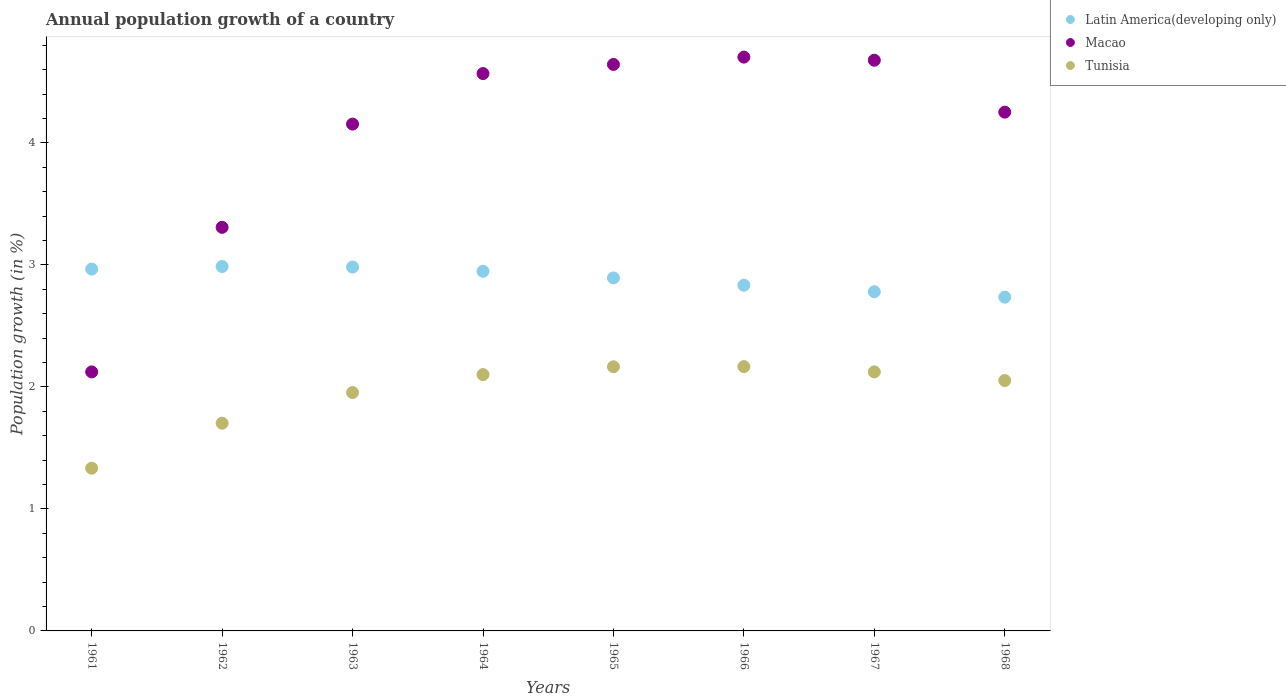How many different coloured dotlines are there?
Provide a succinct answer. 3. Is the number of dotlines equal to the number of legend labels?
Your answer should be very brief. Yes. What is the annual population growth in Macao in 1968?
Offer a very short reply. 4.25. Across all years, what is the maximum annual population growth in Latin America(developing only)?
Keep it short and to the point. 2.99. Across all years, what is the minimum annual population growth in Tunisia?
Your answer should be very brief. 1.33. In which year was the annual population growth in Tunisia maximum?
Provide a short and direct response. 1966. In which year was the annual population growth in Latin America(developing only) minimum?
Your answer should be very brief. 1968. What is the total annual population growth in Latin America(developing only) in the graph?
Make the answer very short. 23.13. What is the difference between the annual population growth in Latin America(developing only) in 1961 and that in 1963?
Your response must be concise. -0.02. What is the difference between the annual population growth in Latin America(developing only) in 1966 and the annual population growth in Tunisia in 1961?
Give a very brief answer. 1.5. What is the average annual population growth in Latin America(developing only) per year?
Offer a terse response. 2.89. In the year 1961, what is the difference between the annual population growth in Tunisia and annual population growth in Macao?
Keep it short and to the point. -0.79. In how many years, is the annual population growth in Tunisia greater than 1 %?
Offer a very short reply. 8. What is the ratio of the annual population growth in Macao in 1965 to that in 1967?
Your answer should be very brief. 0.99. Is the annual population growth in Macao in 1961 less than that in 1965?
Make the answer very short. Yes. Is the difference between the annual population growth in Tunisia in 1966 and 1967 greater than the difference between the annual population growth in Macao in 1966 and 1967?
Your response must be concise. Yes. What is the difference between the highest and the second highest annual population growth in Latin America(developing only)?
Offer a terse response. 0. What is the difference between the highest and the lowest annual population growth in Latin America(developing only)?
Offer a terse response. 0.25. In how many years, is the annual population growth in Tunisia greater than the average annual population growth in Tunisia taken over all years?
Provide a succinct answer. 6. Is the annual population growth in Latin America(developing only) strictly greater than the annual population growth in Macao over the years?
Offer a very short reply. No. How many dotlines are there?
Your answer should be very brief. 3. What is the difference between two consecutive major ticks on the Y-axis?
Give a very brief answer. 1. Does the graph contain grids?
Provide a short and direct response. No. How many legend labels are there?
Offer a terse response. 3. How are the legend labels stacked?
Give a very brief answer. Vertical. What is the title of the graph?
Ensure brevity in your answer.  Annual population growth of a country. Does "Bangladesh" appear as one of the legend labels in the graph?
Give a very brief answer. No. What is the label or title of the X-axis?
Keep it short and to the point. Years. What is the label or title of the Y-axis?
Your answer should be compact. Population growth (in %). What is the Population growth (in %) of Latin America(developing only) in 1961?
Your response must be concise. 2.97. What is the Population growth (in %) in Macao in 1961?
Provide a short and direct response. 2.12. What is the Population growth (in %) in Tunisia in 1961?
Your answer should be compact. 1.33. What is the Population growth (in %) of Latin America(developing only) in 1962?
Make the answer very short. 2.99. What is the Population growth (in %) in Macao in 1962?
Make the answer very short. 3.31. What is the Population growth (in %) of Tunisia in 1962?
Offer a terse response. 1.7. What is the Population growth (in %) in Latin America(developing only) in 1963?
Ensure brevity in your answer.  2.98. What is the Population growth (in %) in Macao in 1963?
Provide a short and direct response. 4.15. What is the Population growth (in %) of Tunisia in 1963?
Your response must be concise. 1.95. What is the Population growth (in %) in Latin America(developing only) in 1964?
Your answer should be compact. 2.95. What is the Population growth (in %) of Macao in 1964?
Offer a terse response. 4.57. What is the Population growth (in %) of Tunisia in 1964?
Give a very brief answer. 2.1. What is the Population growth (in %) of Latin America(developing only) in 1965?
Provide a succinct answer. 2.89. What is the Population growth (in %) in Macao in 1965?
Provide a short and direct response. 4.64. What is the Population growth (in %) of Tunisia in 1965?
Offer a very short reply. 2.17. What is the Population growth (in %) of Latin America(developing only) in 1966?
Provide a short and direct response. 2.83. What is the Population growth (in %) in Macao in 1966?
Give a very brief answer. 4.7. What is the Population growth (in %) in Tunisia in 1966?
Ensure brevity in your answer.  2.17. What is the Population growth (in %) in Latin America(developing only) in 1967?
Offer a very short reply. 2.78. What is the Population growth (in %) of Macao in 1967?
Keep it short and to the point. 4.68. What is the Population growth (in %) in Tunisia in 1967?
Give a very brief answer. 2.12. What is the Population growth (in %) of Latin America(developing only) in 1968?
Offer a very short reply. 2.74. What is the Population growth (in %) in Macao in 1968?
Your response must be concise. 4.25. What is the Population growth (in %) of Tunisia in 1968?
Make the answer very short. 2.05. Across all years, what is the maximum Population growth (in %) in Latin America(developing only)?
Your answer should be compact. 2.99. Across all years, what is the maximum Population growth (in %) in Macao?
Offer a very short reply. 4.7. Across all years, what is the maximum Population growth (in %) in Tunisia?
Offer a very short reply. 2.17. Across all years, what is the minimum Population growth (in %) in Latin America(developing only)?
Offer a terse response. 2.74. Across all years, what is the minimum Population growth (in %) of Macao?
Make the answer very short. 2.12. Across all years, what is the minimum Population growth (in %) in Tunisia?
Keep it short and to the point. 1.33. What is the total Population growth (in %) of Latin America(developing only) in the graph?
Offer a terse response. 23.13. What is the total Population growth (in %) in Macao in the graph?
Ensure brevity in your answer.  32.43. What is the total Population growth (in %) of Tunisia in the graph?
Provide a short and direct response. 15.6. What is the difference between the Population growth (in %) in Latin America(developing only) in 1961 and that in 1962?
Offer a terse response. -0.02. What is the difference between the Population growth (in %) in Macao in 1961 and that in 1962?
Your response must be concise. -1.18. What is the difference between the Population growth (in %) of Tunisia in 1961 and that in 1962?
Make the answer very short. -0.37. What is the difference between the Population growth (in %) in Latin America(developing only) in 1961 and that in 1963?
Your answer should be very brief. -0.02. What is the difference between the Population growth (in %) of Macao in 1961 and that in 1963?
Provide a short and direct response. -2.03. What is the difference between the Population growth (in %) in Tunisia in 1961 and that in 1963?
Provide a succinct answer. -0.62. What is the difference between the Population growth (in %) in Latin America(developing only) in 1961 and that in 1964?
Ensure brevity in your answer.  0.02. What is the difference between the Population growth (in %) of Macao in 1961 and that in 1964?
Your answer should be very brief. -2.44. What is the difference between the Population growth (in %) of Tunisia in 1961 and that in 1964?
Provide a short and direct response. -0.77. What is the difference between the Population growth (in %) of Latin America(developing only) in 1961 and that in 1965?
Make the answer very short. 0.07. What is the difference between the Population growth (in %) in Macao in 1961 and that in 1965?
Ensure brevity in your answer.  -2.52. What is the difference between the Population growth (in %) of Tunisia in 1961 and that in 1965?
Provide a succinct answer. -0.83. What is the difference between the Population growth (in %) of Latin America(developing only) in 1961 and that in 1966?
Provide a succinct answer. 0.13. What is the difference between the Population growth (in %) of Macao in 1961 and that in 1966?
Offer a terse response. -2.58. What is the difference between the Population growth (in %) in Tunisia in 1961 and that in 1966?
Offer a terse response. -0.83. What is the difference between the Population growth (in %) of Latin America(developing only) in 1961 and that in 1967?
Your answer should be compact. 0.19. What is the difference between the Population growth (in %) of Macao in 1961 and that in 1967?
Your answer should be very brief. -2.55. What is the difference between the Population growth (in %) in Tunisia in 1961 and that in 1967?
Keep it short and to the point. -0.79. What is the difference between the Population growth (in %) of Latin America(developing only) in 1961 and that in 1968?
Provide a short and direct response. 0.23. What is the difference between the Population growth (in %) in Macao in 1961 and that in 1968?
Your answer should be very brief. -2.13. What is the difference between the Population growth (in %) of Tunisia in 1961 and that in 1968?
Give a very brief answer. -0.72. What is the difference between the Population growth (in %) of Latin America(developing only) in 1962 and that in 1963?
Give a very brief answer. 0. What is the difference between the Population growth (in %) in Macao in 1962 and that in 1963?
Offer a very short reply. -0.85. What is the difference between the Population growth (in %) of Tunisia in 1962 and that in 1963?
Offer a very short reply. -0.25. What is the difference between the Population growth (in %) of Latin America(developing only) in 1962 and that in 1964?
Provide a short and direct response. 0.04. What is the difference between the Population growth (in %) of Macao in 1962 and that in 1964?
Make the answer very short. -1.26. What is the difference between the Population growth (in %) in Tunisia in 1962 and that in 1964?
Your answer should be very brief. -0.4. What is the difference between the Population growth (in %) of Latin America(developing only) in 1962 and that in 1965?
Ensure brevity in your answer.  0.09. What is the difference between the Population growth (in %) in Macao in 1962 and that in 1965?
Ensure brevity in your answer.  -1.34. What is the difference between the Population growth (in %) of Tunisia in 1962 and that in 1965?
Make the answer very short. -0.46. What is the difference between the Population growth (in %) of Latin America(developing only) in 1962 and that in 1966?
Keep it short and to the point. 0.15. What is the difference between the Population growth (in %) in Macao in 1962 and that in 1966?
Provide a short and direct response. -1.4. What is the difference between the Population growth (in %) of Tunisia in 1962 and that in 1966?
Provide a succinct answer. -0.46. What is the difference between the Population growth (in %) in Latin America(developing only) in 1962 and that in 1967?
Your answer should be compact. 0.21. What is the difference between the Population growth (in %) in Macao in 1962 and that in 1967?
Provide a short and direct response. -1.37. What is the difference between the Population growth (in %) in Tunisia in 1962 and that in 1967?
Your response must be concise. -0.42. What is the difference between the Population growth (in %) of Latin America(developing only) in 1962 and that in 1968?
Offer a terse response. 0.25. What is the difference between the Population growth (in %) of Macao in 1962 and that in 1968?
Provide a succinct answer. -0.94. What is the difference between the Population growth (in %) of Tunisia in 1962 and that in 1968?
Keep it short and to the point. -0.35. What is the difference between the Population growth (in %) in Latin America(developing only) in 1963 and that in 1964?
Your answer should be very brief. 0.03. What is the difference between the Population growth (in %) of Macao in 1963 and that in 1964?
Make the answer very short. -0.41. What is the difference between the Population growth (in %) in Tunisia in 1963 and that in 1964?
Make the answer very short. -0.15. What is the difference between the Population growth (in %) of Latin America(developing only) in 1963 and that in 1965?
Your answer should be very brief. 0.09. What is the difference between the Population growth (in %) of Macao in 1963 and that in 1965?
Keep it short and to the point. -0.49. What is the difference between the Population growth (in %) of Tunisia in 1963 and that in 1965?
Provide a short and direct response. -0.21. What is the difference between the Population growth (in %) of Latin America(developing only) in 1963 and that in 1966?
Give a very brief answer. 0.15. What is the difference between the Population growth (in %) of Macao in 1963 and that in 1966?
Provide a succinct answer. -0.55. What is the difference between the Population growth (in %) in Tunisia in 1963 and that in 1966?
Make the answer very short. -0.21. What is the difference between the Population growth (in %) in Latin America(developing only) in 1963 and that in 1967?
Offer a terse response. 0.2. What is the difference between the Population growth (in %) in Macao in 1963 and that in 1967?
Make the answer very short. -0.52. What is the difference between the Population growth (in %) of Tunisia in 1963 and that in 1967?
Provide a short and direct response. -0.17. What is the difference between the Population growth (in %) in Latin America(developing only) in 1963 and that in 1968?
Provide a succinct answer. 0.25. What is the difference between the Population growth (in %) of Macao in 1963 and that in 1968?
Give a very brief answer. -0.1. What is the difference between the Population growth (in %) in Tunisia in 1963 and that in 1968?
Provide a succinct answer. -0.1. What is the difference between the Population growth (in %) in Latin America(developing only) in 1964 and that in 1965?
Your answer should be very brief. 0.05. What is the difference between the Population growth (in %) of Macao in 1964 and that in 1965?
Provide a short and direct response. -0.07. What is the difference between the Population growth (in %) of Tunisia in 1964 and that in 1965?
Your answer should be very brief. -0.06. What is the difference between the Population growth (in %) in Latin America(developing only) in 1964 and that in 1966?
Your answer should be very brief. 0.11. What is the difference between the Population growth (in %) of Macao in 1964 and that in 1966?
Offer a terse response. -0.13. What is the difference between the Population growth (in %) of Tunisia in 1964 and that in 1966?
Provide a short and direct response. -0.07. What is the difference between the Population growth (in %) in Latin America(developing only) in 1964 and that in 1967?
Your answer should be compact. 0.17. What is the difference between the Population growth (in %) of Macao in 1964 and that in 1967?
Your answer should be very brief. -0.11. What is the difference between the Population growth (in %) in Tunisia in 1964 and that in 1967?
Make the answer very short. -0.02. What is the difference between the Population growth (in %) of Latin America(developing only) in 1964 and that in 1968?
Provide a short and direct response. 0.21. What is the difference between the Population growth (in %) of Macao in 1964 and that in 1968?
Make the answer very short. 0.32. What is the difference between the Population growth (in %) in Tunisia in 1964 and that in 1968?
Offer a very short reply. 0.05. What is the difference between the Population growth (in %) in Latin America(developing only) in 1965 and that in 1966?
Make the answer very short. 0.06. What is the difference between the Population growth (in %) in Macao in 1965 and that in 1966?
Your response must be concise. -0.06. What is the difference between the Population growth (in %) of Tunisia in 1965 and that in 1966?
Provide a succinct answer. -0. What is the difference between the Population growth (in %) in Latin America(developing only) in 1965 and that in 1967?
Offer a very short reply. 0.11. What is the difference between the Population growth (in %) of Macao in 1965 and that in 1967?
Keep it short and to the point. -0.03. What is the difference between the Population growth (in %) in Tunisia in 1965 and that in 1967?
Offer a very short reply. 0.04. What is the difference between the Population growth (in %) of Latin America(developing only) in 1965 and that in 1968?
Ensure brevity in your answer.  0.16. What is the difference between the Population growth (in %) in Macao in 1965 and that in 1968?
Ensure brevity in your answer.  0.39. What is the difference between the Population growth (in %) of Tunisia in 1965 and that in 1968?
Your response must be concise. 0.11. What is the difference between the Population growth (in %) of Latin America(developing only) in 1966 and that in 1967?
Ensure brevity in your answer.  0.05. What is the difference between the Population growth (in %) of Macao in 1966 and that in 1967?
Your answer should be very brief. 0.03. What is the difference between the Population growth (in %) of Tunisia in 1966 and that in 1967?
Give a very brief answer. 0.04. What is the difference between the Population growth (in %) in Latin America(developing only) in 1966 and that in 1968?
Offer a terse response. 0.1. What is the difference between the Population growth (in %) in Macao in 1966 and that in 1968?
Keep it short and to the point. 0.45. What is the difference between the Population growth (in %) in Tunisia in 1966 and that in 1968?
Provide a succinct answer. 0.11. What is the difference between the Population growth (in %) in Latin America(developing only) in 1967 and that in 1968?
Your response must be concise. 0.04. What is the difference between the Population growth (in %) of Macao in 1967 and that in 1968?
Make the answer very short. 0.43. What is the difference between the Population growth (in %) in Tunisia in 1967 and that in 1968?
Your response must be concise. 0.07. What is the difference between the Population growth (in %) of Latin America(developing only) in 1961 and the Population growth (in %) of Macao in 1962?
Offer a very short reply. -0.34. What is the difference between the Population growth (in %) in Latin America(developing only) in 1961 and the Population growth (in %) in Tunisia in 1962?
Your answer should be very brief. 1.26. What is the difference between the Population growth (in %) in Macao in 1961 and the Population growth (in %) in Tunisia in 1962?
Ensure brevity in your answer.  0.42. What is the difference between the Population growth (in %) of Latin America(developing only) in 1961 and the Population growth (in %) of Macao in 1963?
Offer a very short reply. -1.19. What is the difference between the Population growth (in %) of Latin America(developing only) in 1961 and the Population growth (in %) of Tunisia in 1963?
Provide a succinct answer. 1.01. What is the difference between the Population growth (in %) of Macao in 1961 and the Population growth (in %) of Tunisia in 1963?
Your response must be concise. 0.17. What is the difference between the Population growth (in %) in Latin America(developing only) in 1961 and the Population growth (in %) in Macao in 1964?
Make the answer very short. -1.6. What is the difference between the Population growth (in %) in Latin America(developing only) in 1961 and the Population growth (in %) in Tunisia in 1964?
Your answer should be very brief. 0.86. What is the difference between the Population growth (in %) of Macao in 1961 and the Population growth (in %) of Tunisia in 1964?
Your answer should be compact. 0.02. What is the difference between the Population growth (in %) of Latin America(developing only) in 1961 and the Population growth (in %) of Macao in 1965?
Provide a succinct answer. -1.68. What is the difference between the Population growth (in %) in Latin America(developing only) in 1961 and the Population growth (in %) in Tunisia in 1965?
Your answer should be very brief. 0.8. What is the difference between the Population growth (in %) of Macao in 1961 and the Population growth (in %) of Tunisia in 1965?
Your answer should be compact. -0.04. What is the difference between the Population growth (in %) of Latin America(developing only) in 1961 and the Population growth (in %) of Macao in 1966?
Your response must be concise. -1.74. What is the difference between the Population growth (in %) in Latin America(developing only) in 1961 and the Population growth (in %) in Tunisia in 1966?
Offer a very short reply. 0.8. What is the difference between the Population growth (in %) in Macao in 1961 and the Population growth (in %) in Tunisia in 1966?
Make the answer very short. -0.04. What is the difference between the Population growth (in %) in Latin America(developing only) in 1961 and the Population growth (in %) in Macao in 1967?
Give a very brief answer. -1.71. What is the difference between the Population growth (in %) in Latin America(developing only) in 1961 and the Population growth (in %) in Tunisia in 1967?
Make the answer very short. 0.84. What is the difference between the Population growth (in %) in Macao in 1961 and the Population growth (in %) in Tunisia in 1967?
Offer a very short reply. -0. What is the difference between the Population growth (in %) of Latin America(developing only) in 1961 and the Population growth (in %) of Macao in 1968?
Offer a terse response. -1.29. What is the difference between the Population growth (in %) in Latin America(developing only) in 1961 and the Population growth (in %) in Tunisia in 1968?
Your response must be concise. 0.91. What is the difference between the Population growth (in %) in Macao in 1961 and the Population growth (in %) in Tunisia in 1968?
Offer a very short reply. 0.07. What is the difference between the Population growth (in %) in Latin America(developing only) in 1962 and the Population growth (in %) in Macao in 1963?
Ensure brevity in your answer.  -1.17. What is the difference between the Population growth (in %) of Latin America(developing only) in 1962 and the Population growth (in %) of Tunisia in 1963?
Your answer should be very brief. 1.03. What is the difference between the Population growth (in %) of Macao in 1962 and the Population growth (in %) of Tunisia in 1963?
Your response must be concise. 1.35. What is the difference between the Population growth (in %) of Latin America(developing only) in 1962 and the Population growth (in %) of Macao in 1964?
Make the answer very short. -1.58. What is the difference between the Population growth (in %) in Latin America(developing only) in 1962 and the Population growth (in %) in Tunisia in 1964?
Ensure brevity in your answer.  0.89. What is the difference between the Population growth (in %) of Macao in 1962 and the Population growth (in %) of Tunisia in 1964?
Your answer should be very brief. 1.21. What is the difference between the Population growth (in %) in Latin America(developing only) in 1962 and the Population growth (in %) in Macao in 1965?
Make the answer very short. -1.66. What is the difference between the Population growth (in %) of Latin America(developing only) in 1962 and the Population growth (in %) of Tunisia in 1965?
Ensure brevity in your answer.  0.82. What is the difference between the Population growth (in %) in Macao in 1962 and the Population growth (in %) in Tunisia in 1965?
Provide a succinct answer. 1.14. What is the difference between the Population growth (in %) of Latin America(developing only) in 1962 and the Population growth (in %) of Macao in 1966?
Ensure brevity in your answer.  -1.72. What is the difference between the Population growth (in %) of Latin America(developing only) in 1962 and the Population growth (in %) of Tunisia in 1966?
Ensure brevity in your answer.  0.82. What is the difference between the Population growth (in %) in Macao in 1962 and the Population growth (in %) in Tunisia in 1966?
Provide a succinct answer. 1.14. What is the difference between the Population growth (in %) of Latin America(developing only) in 1962 and the Population growth (in %) of Macao in 1967?
Keep it short and to the point. -1.69. What is the difference between the Population growth (in %) of Latin America(developing only) in 1962 and the Population growth (in %) of Tunisia in 1967?
Offer a terse response. 0.86. What is the difference between the Population growth (in %) in Macao in 1962 and the Population growth (in %) in Tunisia in 1967?
Provide a succinct answer. 1.18. What is the difference between the Population growth (in %) of Latin America(developing only) in 1962 and the Population growth (in %) of Macao in 1968?
Give a very brief answer. -1.27. What is the difference between the Population growth (in %) in Latin America(developing only) in 1962 and the Population growth (in %) in Tunisia in 1968?
Your answer should be very brief. 0.93. What is the difference between the Population growth (in %) of Macao in 1962 and the Population growth (in %) of Tunisia in 1968?
Your answer should be very brief. 1.26. What is the difference between the Population growth (in %) of Latin America(developing only) in 1963 and the Population growth (in %) of Macao in 1964?
Offer a very short reply. -1.59. What is the difference between the Population growth (in %) in Latin America(developing only) in 1963 and the Population growth (in %) in Tunisia in 1964?
Provide a short and direct response. 0.88. What is the difference between the Population growth (in %) of Macao in 1963 and the Population growth (in %) of Tunisia in 1964?
Ensure brevity in your answer.  2.05. What is the difference between the Population growth (in %) of Latin America(developing only) in 1963 and the Population growth (in %) of Macao in 1965?
Provide a short and direct response. -1.66. What is the difference between the Population growth (in %) of Latin America(developing only) in 1963 and the Population growth (in %) of Tunisia in 1965?
Your answer should be compact. 0.82. What is the difference between the Population growth (in %) of Macao in 1963 and the Population growth (in %) of Tunisia in 1965?
Provide a short and direct response. 1.99. What is the difference between the Population growth (in %) in Latin America(developing only) in 1963 and the Population growth (in %) in Macao in 1966?
Provide a short and direct response. -1.72. What is the difference between the Population growth (in %) in Latin America(developing only) in 1963 and the Population growth (in %) in Tunisia in 1966?
Give a very brief answer. 0.82. What is the difference between the Population growth (in %) of Macao in 1963 and the Population growth (in %) of Tunisia in 1966?
Provide a succinct answer. 1.99. What is the difference between the Population growth (in %) of Latin America(developing only) in 1963 and the Population growth (in %) of Macao in 1967?
Give a very brief answer. -1.7. What is the difference between the Population growth (in %) in Latin America(developing only) in 1963 and the Population growth (in %) in Tunisia in 1967?
Your response must be concise. 0.86. What is the difference between the Population growth (in %) in Macao in 1963 and the Population growth (in %) in Tunisia in 1967?
Keep it short and to the point. 2.03. What is the difference between the Population growth (in %) of Latin America(developing only) in 1963 and the Population growth (in %) of Macao in 1968?
Your answer should be compact. -1.27. What is the difference between the Population growth (in %) in Latin America(developing only) in 1963 and the Population growth (in %) in Tunisia in 1968?
Keep it short and to the point. 0.93. What is the difference between the Population growth (in %) in Macao in 1963 and the Population growth (in %) in Tunisia in 1968?
Provide a succinct answer. 2.1. What is the difference between the Population growth (in %) in Latin America(developing only) in 1964 and the Population growth (in %) in Macao in 1965?
Keep it short and to the point. -1.7. What is the difference between the Population growth (in %) of Latin America(developing only) in 1964 and the Population growth (in %) of Tunisia in 1965?
Give a very brief answer. 0.78. What is the difference between the Population growth (in %) of Macao in 1964 and the Population growth (in %) of Tunisia in 1965?
Ensure brevity in your answer.  2.4. What is the difference between the Population growth (in %) of Latin America(developing only) in 1964 and the Population growth (in %) of Macao in 1966?
Give a very brief answer. -1.76. What is the difference between the Population growth (in %) of Latin America(developing only) in 1964 and the Population growth (in %) of Tunisia in 1966?
Provide a succinct answer. 0.78. What is the difference between the Population growth (in %) of Macao in 1964 and the Population growth (in %) of Tunisia in 1966?
Your response must be concise. 2.4. What is the difference between the Population growth (in %) in Latin America(developing only) in 1964 and the Population growth (in %) in Macao in 1967?
Your response must be concise. -1.73. What is the difference between the Population growth (in %) of Latin America(developing only) in 1964 and the Population growth (in %) of Tunisia in 1967?
Make the answer very short. 0.82. What is the difference between the Population growth (in %) in Macao in 1964 and the Population growth (in %) in Tunisia in 1967?
Provide a short and direct response. 2.44. What is the difference between the Population growth (in %) of Latin America(developing only) in 1964 and the Population growth (in %) of Macao in 1968?
Keep it short and to the point. -1.3. What is the difference between the Population growth (in %) in Latin America(developing only) in 1964 and the Population growth (in %) in Tunisia in 1968?
Your answer should be compact. 0.9. What is the difference between the Population growth (in %) of Macao in 1964 and the Population growth (in %) of Tunisia in 1968?
Ensure brevity in your answer.  2.52. What is the difference between the Population growth (in %) in Latin America(developing only) in 1965 and the Population growth (in %) in Macao in 1966?
Make the answer very short. -1.81. What is the difference between the Population growth (in %) of Latin America(developing only) in 1965 and the Population growth (in %) of Tunisia in 1966?
Make the answer very short. 0.73. What is the difference between the Population growth (in %) in Macao in 1965 and the Population growth (in %) in Tunisia in 1966?
Your response must be concise. 2.48. What is the difference between the Population growth (in %) of Latin America(developing only) in 1965 and the Population growth (in %) of Macao in 1967?
Your answer should be very brief. -1.78. What is the difference between the Population growth (in %) in Latin America(developing only) in 1965 and the Population growth (in %) in Tunisia in 1967?
Keep it short and to the point. 0.77. What is the difference between the Population growth (in %) in Macao in 1965 and the Population growth (in %) in Tunisia in 1967?
Give a very brief answer. 2.52. What is the difference between the Population growth (in %) of Latin America(developing only) in 1965 and the Population growth (in %) of Macao in 1968?
Offer a terse response. -1.36. What is the difference between the Population growth (in %) in Latin America(developing only) in 1965 and the Population growth (in %) in Tunisia in 1968?
Offer a very short reply. 0.84. What is the difference between the Population growth (in %) of Macao in 1965 and the Population growth (in %) of Tunisia in 1968?
Make the answer very short. 2.59. What is the difference between the Population growth (in %) in Latin America(developing only) in 1966 and the Population growth (in %) in Macao in 1967?
Offer a terse response. -1.84. What is the difference between the Population growth (in %) of Latin America(developing only) in 1966 and the Population growth (in %) of Tunisia in 1967?
Your answer should be very brief. 0.71. What is the difference between the Population growth (in %) in Macao in 1966 and the Population growth (in %) in Tunisia in 1967?
Provide a short and direct response. 2.58. What is the difference between the Population growth (in %) of Latin America(developing only) in 1966 and the Population growth (in %) of Macao in 1968?
Ensure brevity in your answer.  -1.42. What is the difference between the Population growth (in %) in Latin America(developing only) in 1966 and the Population growth (in %) in Tunisia in 1968?
Your answer should be very brief. 0.78. What is the difference between the Population growth (in %) of Macao in 1966 and the Population growth (in %) of Tunisia in 1968?
Offer a very short reply. 2.65. What is the difference between the Population growth (in %) in Latin America(developing only) in 1967 and the Population growth (in %) in Macao in 1968?
Offer a very short reply. -1.47. What is the difference between the Population growth (in %) of Latin America(developing only) in 1967 and the Population growth (in %) of Tunisia in 1968?
Your answer should be very brief. 0.73. What is the difference between the Population growth (in %) of Macao in 1967 and the Population growth (in %) of Tunisia in 1968?
Provide a short and direct response. 2.63. What is the average Population growth (in %) of Latin America(developing only) per year?
Provide a short and direct response. 2.89. What is the average Population growth (in %) in Macao per year?
Ensure brevity in your answer.  4.05. What is the average Population growth (in %) in Tunisia per year?
Provide a short and direct response. 1.95. In the year 1961, what is the difference between the Population growth (in %) of Latin America(developing only) and Population growth (in %) of Macao?
Your response must be concise. 0.84. In the year 1961, what is the difference between the Population growth (in %) in Latin America(developing only) and Population growth (in %) in Tunisia?
Your answer should be compact. 1.63. In the year 1961, what is the difference between the Population growth (in %) in Macao and Population growth (in %) in Tunisia?
Ensure brevity in your answer.  0.79. In the year 1962, what is the difference between the Population growth (in %) of Latin America(developing only) and Population growth (in %) of Macao?
Ensure brevity in your answer.  -0.32. In the year 1962, what is the difference between the Population growth (in %) of Latin America(developing only) and Population growth (in %) of Tunisia?
Your answer should be compact. 1.28. In the year 1962, what is the difference between the Population growth (in %) in Macao and Population growth (in %) in Tunisia?
Give a very brief answer. 1.61. In the year 1963, what is the difference between the Population growth (in %) in Latin America(developing only) and Population growth (in %) in Macao?
Your response must be concise. -1.17. In the year 1963, what is the difference between the Population growth (in %) of Latin America(developing only) and Population growth (in %) of Tunisia?
Make the answer very short. 1.03. In the year 1963, what is the difference between the Population growth (in %) of Macao and Population growth (in %) of Tunisia?
Make the answer very short. 2.2. In the year 1964, what is the difference between the Population growth (in %) in Latin America(developing only) and Population growth (in %) in Macao?
Provide a short and direct response. -1.62. In the year 1964, what is the difference between the Population growth (in %) of Latin America(developing only) and Population growth (in %) of Tunisia?
Make the answer very short. 0.85. In the year 1964, what is the difference between the Population growth (in %) in Macao and Population growth (in %) in Tunisia?
Give a very brief answer. 2.47. In the year 1965, what is the difference between the Population growth (in %) of Latin America(developing only) and Population growth (in %) of Macao?
Keep it short and to the point. -1.75. In the year 1965, what is the difference between the Population growth (in %) in Latin America(developing only) and Population growth (in %) in Tunisia?
Offer a very short reply. 0.73. In the year 1965, what is the difference between the Population growth (in %) of Macao and Population growth (in %) of Tunisia?
Provide a succinct answer. 2.48. In the year 1966, what is the difference between the Population growth (in %) of Latin America(developing only) and Population growth (in %) of Macao?
Your response must be concise. -1.87. In the year 1966, what is the difference between the Population growth (in %) in Latin America(developing only) and Population growth (in %) in Tunisia?
Your answer should be compact. 0.67. In the year 1966, what is the difference between the Population growth (in %) of Macao and Population growth (in %) of Tunisia?
Make the answer very short. 2.54. In the year 1967, what is the difference between the Population growth (in %) in Latin America(developing only) and Population growth (in %) in Macao?
Your response must be concise. -1.9. In the year 1967, what is the difference between the Population growth (in %) in Latin America(developing only) and Population growth (in %) in Tunisia?
Your answer should be compact. 0.66. In the year 1967, what is the difference between the Population growth (in %) of Macao and Population growth (in %) of Tunisia?
Provide a succinct answer. 2.55. In the year 1968, what is the difference between the Population growth (in %) in Latin America(developing only) and Population growth (in %) in Macao?
Your answer should be very brief. -1.52. In the year 1968, what is the difference between the Population growth (in %) of Latin America(developing only) and Population growth (in %) of Tunisia?
Offer a very short reply. 0.68. In the year 1968, what is the difference between the Population growth (in %) of Macao and Population growth (in %) of Tunisia?
Offer a terse response. 2.2. What is the ratio of the Population growth (in %) of Macao in 1961 to that in 1962?
Keep it short and to the point. 0.64. What is the ratio of the Population growth (in %) in Tunisia in 1961 to that in 1962?
Your answer should be compact. 0.78. What is the ratio of the Population growth (in %) in Latin America(developing only) in 1961 to that in 1963?
Give a very brief answer. 0.99. What is the ratio of the Population growth (in %) of Macao in 1961 to that in 1963?
Keep it short and to the point. 0.51. What is the ratio of the Population growth (in %) in Tunisia in 1961 to that in 1963?
Make the answer very short. 0.68. What is the ratio of the Population growth (in %) in Latin America(developing only) in 1961 to that in 1964?
Provide a succinct answer. 1.01. What is the ratio of the Population growth (in %) in Macao in 1961 to that in 1964?
Provide a short and direct response. 0.46. What is the ratio of the Population growth (in %) of Tunisia in 1961 to that in 1964?
Your answer should be very brief. 0.63. What is the ratio of the Population growth (in %) in Latin America(developing only) in 1961 to that in 1965?
Offer a very short reply. 1.03. What is the ratio of the Population growth (in %) of Macao in 1961 to that in 1965?
Your answer should be compact. 0.46. What is the ratio of the Population growth (in %) of Tunisia in 1961 to that in 1965?
Keep it short and to the point. 0.62. What is the ratio of the Population growth (in %) in Latin America(developing only) in 1961 to that in 1966?
Offer a terse response. 1.05. What is the ratio of the Population growth (in %) in Macao in 1961 to that in 1966?
Provide a short and direct response. 0.45. What is the ratio of the Population growth (in %) of Tunisia in 1961 to that in 1966?
Offer a very short reply. 0.62. What is the ratio of the Population growth (in %) of Latin America(developing only) in 1961 to that in 1967?
Provide a succinct answer. 1.07. What is the ratio of the Population growth (in %) of Macao in 1961 to that in 1967?
Ensure brevity in your answer.  0.45. What is the ratio of the Population growth (in %) of Tunisia in 1961 to that in 1967?
Keep it short and to the point. 0.63. What is the ratio of the Population growth (in %) in Latin America(developing only) in 1961 to that in 1968?
Your answer should be compact. 1.08. What is the ratio of the Population growth (in %) in Macao in 1961 to that in 1968?
Make the answer very short. 0.5. What is the ratio of the Population growth (in %) in Tunisia in 1961 to that in 1968?
Offer a very short reply. 0.65. What is the ratio of the Population growth (in %) of Latin America(developing only) in 1962 to that in 1963?
Offer a very short reply. 1. What is the ratio of the Population growth (in %) in Macao in 1962 to that in 1963?
Keep it short and to the point. 0.8. What is the ratio of the Population growth (in %) of Tunisia in 1962 to that in 1963?
Ensure brevity in your answer.  0.87. What is the ratio of the Population growth (in %) in Latin America(developing only) in 1962 to that in 1964?
Ensure brevity in your answer.  1.01. What is the ratio of the Population growth (in %) in Macao in 1962 to that in 1964?
Give a very brief answer. 0.72. What is the ratio of the Population growth (in %) in Tunisia in 1962 to that in 1964?
Offer a very short reply. 0.81. What is the ratio of the Population growth (in %) in Latin America(developing only) in 1962 to that in 1965?
Offer a very short reply. 1.03. What is the ratio of the Population growth (in %) in Macao in 1962 to that in 1965?
Your answer should be very brief. 0.71. What is the ratio of the Population growth (in %) in Tunisia in 1962 to that in 1965?
Ensure brevity in your answer.  0.79. What is the ratio of the Population growth (in %) in Latin America(developing only) in 1962 to that in 1966?
Provide a succinct answer. 1.05. What is the ratio of the Population growth (in %) of Macao in 1962 to that in 1966?
Your answer should be compact. 0.7. What is the ratio of the Population growth (in %) in Tunisia in 1962 to that in 1966?
Offer a terse response. 0.79. What is the ratio of the Population growth (in %) in Latin America(developing only) in 1962 to that in 1967?
Keep it short and to the point. 1.07. What is the ratio of the Population growth (in %) in Macao in 1962 to that in 1967?
Your response must be concise. 0.71. What is the ratio of the Population growth (in %) in Tunisia in 1962 to that in 1967?
Your response must be concise. 0.8. What is the ratio of the Population growth (in %) in Latin America(developing only) in 1962 to that in 1968?
Keep it short and to the point. 1.09. What is the ratio of the Population growth (in %) of Macao in 1962 to that in 1968?
Give a very brief answer. 0.78. What is the ratio of the Population growth (in %) of Tunisia in 1962 to that in 1968?
Your answer should be compact. 0.83. What is the ratio of the Population growth (in %) in Latin America(developing only) in 1963 to that in 1964?
Keep it short and to the point. 1.01. What is the ratio of the Population growth (in %) in Macao in 1963 to that in 1964?
Give a very brief answer. 0.91. What is the ratio of the Population growth (in %) in Tunisia in 1963 to that in 1964?
Your response must be concise. 0.93. What is the ratio of the Population growth (in %) in Latin America(developing only) in 1963 to that in 1965?
Keep it short and to the point. 1.03. What is the ratio of the Population growth (in %) in Macao in 1963 to that in 1965?
Ensure brevity in your answer.  0.89. What is the ratio of the Population growth (in %) of Tunisia in 1963 to that in 1965?
Your answer should be compact. 0.9. What is the ratio of the Population growth (in %) of Latin America(developing only) in 1963 to that in 1966?
Provide a short and direct response. 1.05. What is the ratio of the Population growth (in %) of Macao in 1963 to that in 1966?
Offer a very short reply. 0.88. What is the ratio of the Population growth (in %) in Tunisia in 1963 to that in 1966?
Provide a succinct answer. 0.9. What is the ratio of the Population growth (in %) of Latin America(developing only) in 1963 to that in 1967?
Provide a short and direct response. 1.07. What is the ratio of the Population growth (in %) of Macao in 1963 to that in 1967?
Give a very brief answer. 0.89. What is the ratio of the Population growth (in %) in Tunisia in 1963 to that in 1967?
Keep it short and to the point. 0.92. What is the ratio of the Population growth (in %) of Latin America(developing only) in 1963 to that in 1968?
Give a very brief answer. 1.09. What is the ratio of the Population growth (in %) of Tunisia in 1963 to that in 1968?
Give a very brief answer. 0.95. What is the ratio of the Population growth (in %) of Latin America(developing only) in 1964 to that in 1965?
Keep it short and to the point. 1.02. What is the ratio of the Population growth (in %) of Macao in 1964 to that in 1965?
Your response must be concise. 0.98. What is the ratio of the Population growth (in %) of Tunisia in 1964 to that in 1965?
Provide a short and direct response. 0.97. What is the ratio of the Population growth (in %) in Latin America(developing only) in 1964 to that in 1966?
Your answer should be compact. 1.04. What is the ratio of the Population growth (in %) of Macao in 1964 to that in 1966?
Make the answer very short. 0.97. What is the ratio of the Population growth (in %) of Tunisia in 1964 to that in 1966?
Your answer should be compact. 0.97. What is the ratio of the Population growth (in %) of Latin America(developing only) in 1964 to that in 1967?
Offer a terse response. 1.06. What is the ratio of the Population growth (in %) of Macao in 1964 to that in 1967?
Your response must be concise. 0.98. What is the ratio of the Population growth (in %) in Tunisia in 1964 to that in 1967?
Your answer should be very brief. 0.99. What is the ratio of the Population growth (in %) of Latin America(developing only) in 1964 to that in 1968?
Your answer should be compact. 1.08. What is the ratio of the Population growth (in %) of Macao in 1964 to that in 1968?
Ensure brevity in your answer.  1.07. What is the ratio of the Population growth (in %) of Tunisia in 1964 to that in 1968?
Provide a succinct answer. 1.02. What is the ratio of the Population growth (in %) of Latin America(developing only) in 1965 to that in 1966?
Your answer should be compact. 1.02. What is the ratio of the Population growth (in %) of Macao in 1965 to that in 1966?
Make the answer very short. 0.99. What is the ratio of the Population growth (in %) of Tunisia in 1965 to that in 1966?
Provide a succinct answer. 1. What is the ratio of the Population growth (in %) of Latin America(developing only) in 1965 to that in 1967?
Your response must be concise. 1.04. What is the ratio of the Population growth (in %) of Tunisia in 1965 to that in 1967?
Ensure brevity in your answer.  1.02. What is the ratio of the Population growth (in %) in Latin America(developing only) in 1965 to that in 1968?
Give a very brief answer. 1.06. What is the ratio of the Population growth (in %) in Macao in 1965 to that in 1968?
Your answer should be compact. 1.09. What is the ratio of the Population growth (in %) of Tunisia in 1965 to that in 1968?
Your answer should be compact. 1.05. What is the ratio of the Population growth (in %) of Latin America(developing only) in 1966 to that in 1967?
Provide a short and direct response. 1.02. What is the ratio of the Population growth (in %) of Macao in 1966 to that in 1967?
Your answer should be compact. 1.01. What is the ratio of the Population growth (in %) of Tunisia in 1966 to that in 1967?
Keep it short and to the point. 1.02. What is the ratio of the Population growth (in %) of Latin America(developing only) in 1966 to that in 1968?
Ensure brevity in your answer.  1.04. What is the ratio of the Population growth (in %) in Macao in 1966 to that in 1968?
Keep it short and to the point. 1.11. What is the ratio of the Population growth (in %) in Tunisia in 1966 to that in 1968?
Keep it short and to the point. 1.06. What is the ratio of the Population growth (in %) of Latin America(developing only) in 1967 to that in 1968?
Provide a short and direct response. 1.02. What is the ratio of the Population growth (in %) in Macao in 1967 to that in 1968?
Make the answer very short. 1.1. What is the ratio of the Population growth (in %) in Tunisia in 1967 to that in 1968?
Your response must be concise. 1.03. What is the difference between the highest and the second highest Population growth (in %) in Latin America(developing only)?
Provide a short and direct response. 0. What is the difference between the highest and the second highest Population growth (in %) of Macao?
Your answer should be very brief. 0.03. What is the difference between the highest and the second highest Population growth (in %) of Tunisia?
Give a very brief answer. 0. What is the difference between the highest and the lowest Population growth (in %) in Latin America(developing only)?
Your response must be concise. 0.25. What is the difference between the highest and the lowest Population growth (in %) of Macao?
Your answer should be very brief. 2.58. What is the difference between the highest and the lowest Population growth (in %) in Tunisia?
Ensure brevity in your answer.  0.83. 